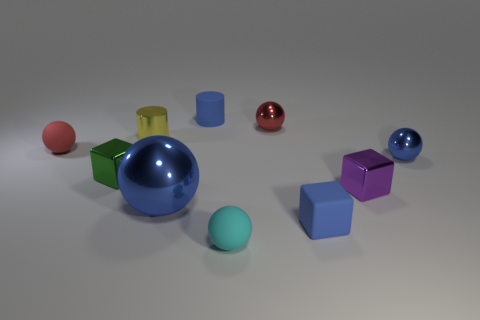How many blue things are behind the yellow cylinder that is behind the blue matte cube?
Give a very brief answer. 1. What number of objects are blue rubber objects that are in front of the yellow cylinder or big cyan cylinders?
Your response must be concise. 1. What is the size of the blue rubber object that is in front of the large blue shiny ball?
Make the answer very short. Small. What material is the yellow object?
Make the answer very short. Metal. What shape is the cyan object to the left of the blue metal ball right of the purple metal block?
Make the answer very short. Sphere. How many other objects are there of the same shape as the small cyan matte thing?
Provide a succinct answer. 4. Are there any large metallic balls to the left of the blue matte cylinder?
Give a very brief answer. Yes. The large metal thing is what color?
Provide a succinct answer. Blue. Is the color of the rubber block the same as the cylinder to the right of the tiny yellow object?
Offer a very short reply. Yes. Are there any red spheres that have the same size as the blue block?
Provide a short and direct response. Yes. 